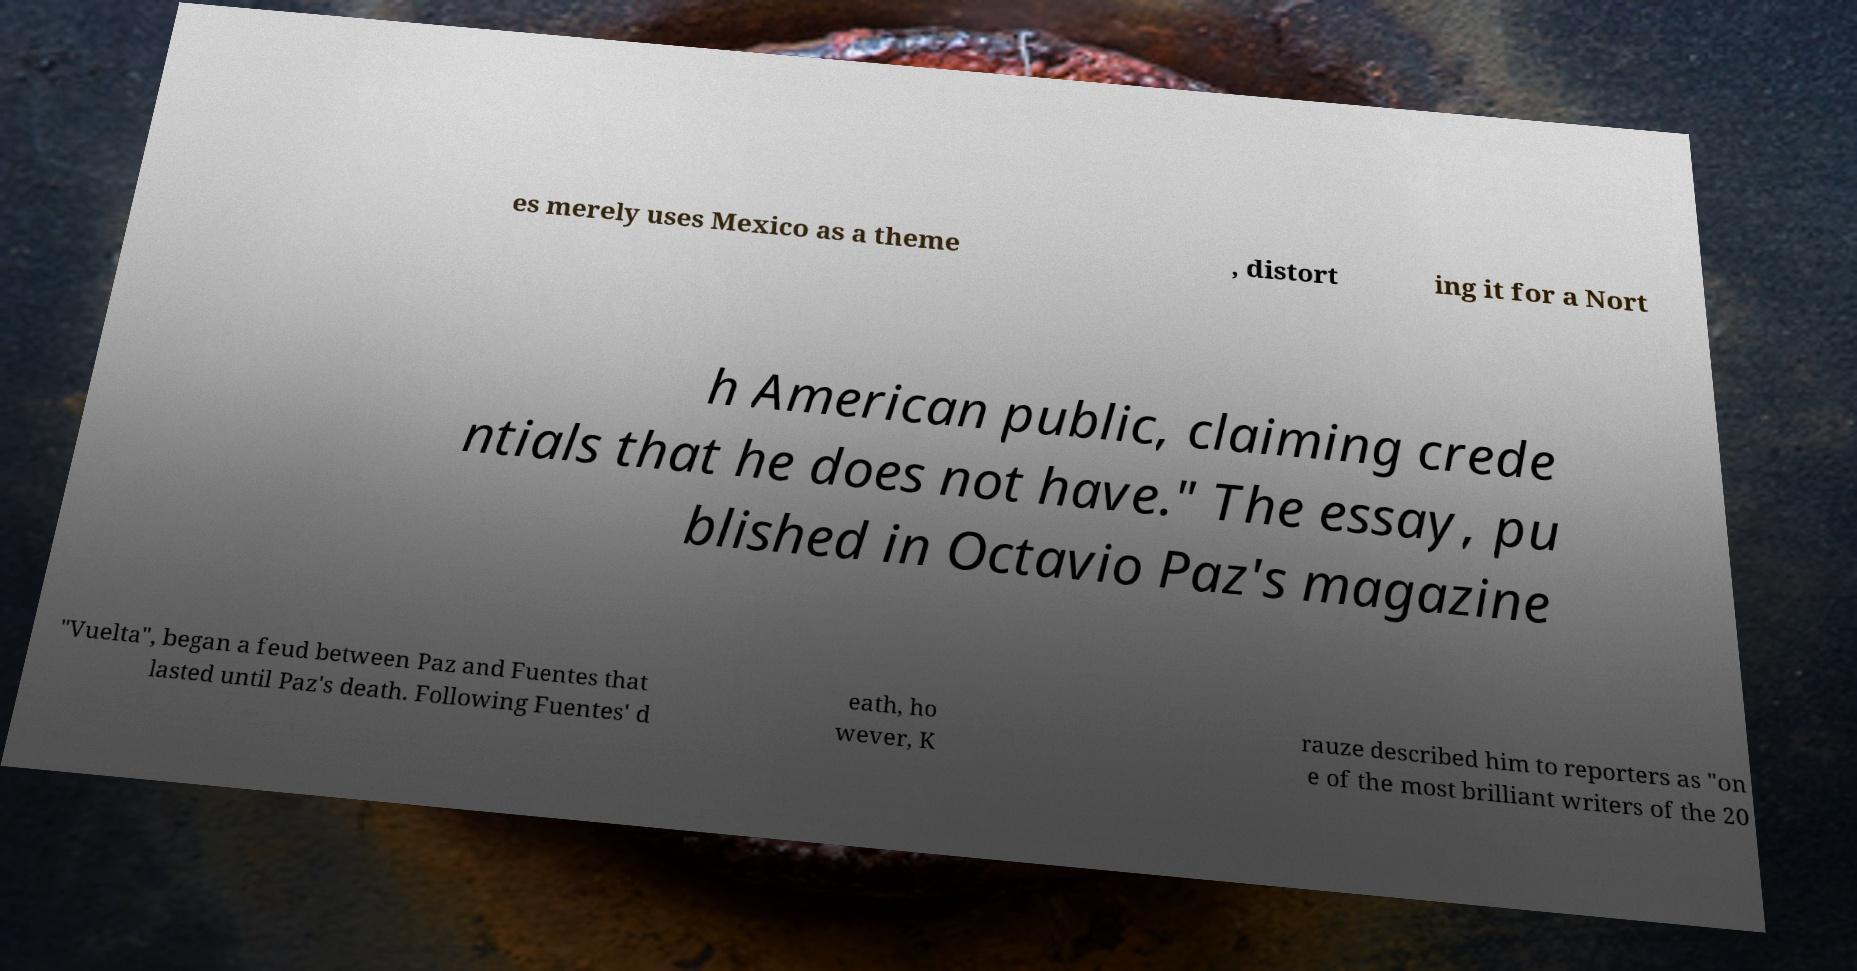Could you extract and type out the text from this image? es merely uses Mexico as a theme , distort ing it for a Nort h American public, claiming crede ntials that he does not have." The essay, pu blished in Octavio Paz's magazine "Vuelta", began a feud between Paz and Fuentes that lasted until Paz's death. Following Fuentes' d eath, ho wever, K rauze described him to reporters as "on e of the most brilliant writers of the 20 